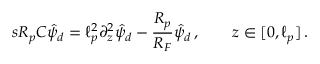<formula> <loc_0><loc_0><loc_500><loc_500>s R _ { p } C \hat { \psi } _ { d } = \ell _ { p } ^ { 2 } \partial _ { z } ^ { 2 } \hat { \psi } _ { d } - \frac { R _ { p } } { R _ { F } } \hat { \psi } _ { d } \, , \quad z \in [ 0 , \ell _ { p } ] \, .</formula> 